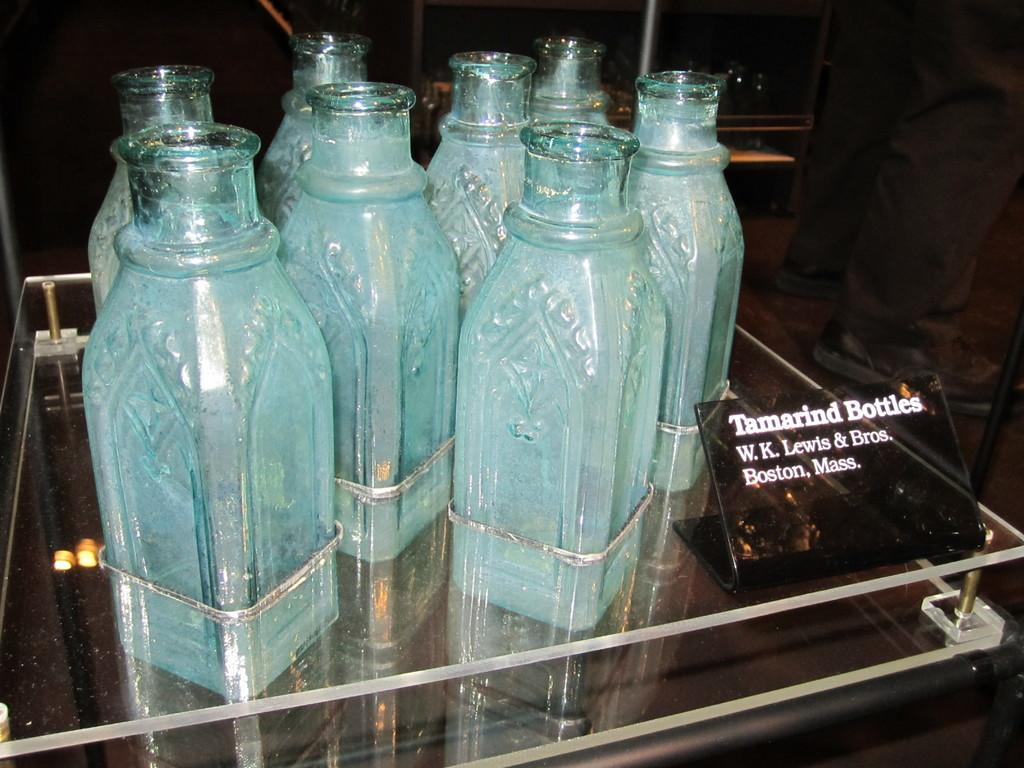What type of objects can be seen in the image? There are bottles and a board with text in the image. How are the objects arranged in the image? The board is in front of the bottles. What is the surface on which the objects are placed? The objects are on a glass table. Can you describe any other elements in the image? A person's legs are visible beside the table. What type of collar can be seen on the person in the image? There is no person visible in the image, only their legs. Therefore, there is no collar present. What type of office furniture can be seen in the image? The image does not depict an office setting, so there is no office furniture present. 